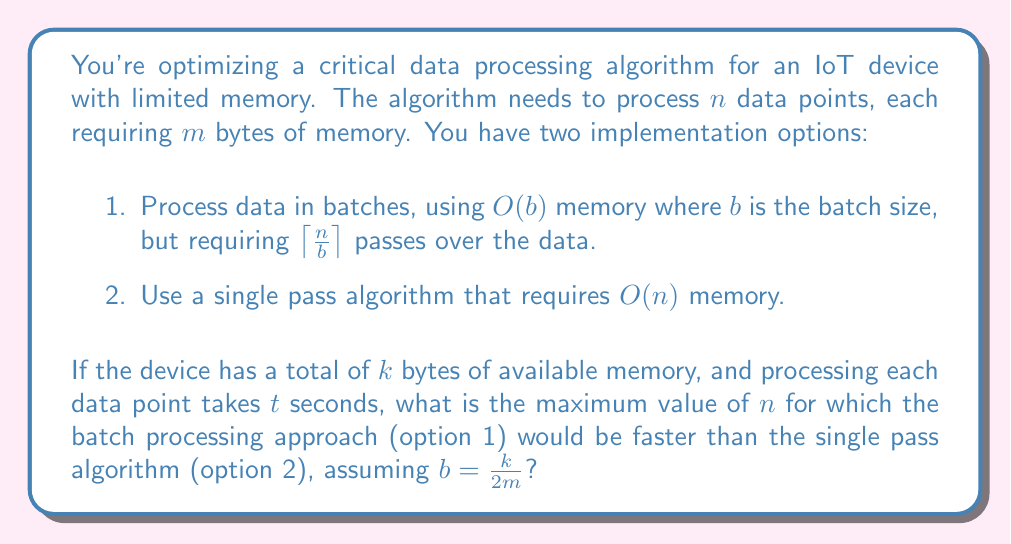Show me your answer to this math problem. Let's approach this step-by-step:

1) First, let's define our constraints:
   - Total memory available: $k$ bytes
   - Memory required per data point: $m$ bytes
   - Batch size: $b = \frac{k}{2m}$ (using half of available memory for batch)
   - Time to process each data point: $t$ seconds

2) For the batch processing approach (option 1):
   - Number of passes required: $\left\lceil\frac{n}{b}\right\rceil$
   - Total time: $T_1 = \left\lceil\frac{n}{b}\right\rceil \cdot n \cdot t$

3) For the single pass algorithm (option 2):
   - Total time: $T_2 = n \cdot t$

4) We want to find the maximum $n$ where $T_1 < T_2$:

   $$\left\lceil\frac{n}{b}\right\rceil \cdot n \cdot t < n \cdot t$$

5) Simplifying:

   $$\left\lceil\frac{n}{b}\right\rceil < 1$$

6) This inequality holds true when $\frac{n}{b} < 1$, or $n < b$

7) Substituting $b = \frac{k}{2m}$:

   $$n < \frac{k}{2m}$$

8) Therefore, the batch processing approach is faster when $n < \frac{k}{2m}$

9) The maximum value of $n$ for which this holds true is:

   $$n_{max} = \left\lfloor\frac{k}{2m}\right\rfloor - 1$$

   We subtract 1 to ensure we're strictly less than $\frac{k}{2m}$.
Answer: The maximum value of $n$ for which the batch processing approach would be faster is $\left\lfloor\frac{k}{2m}\right\rfloor - 1$. 